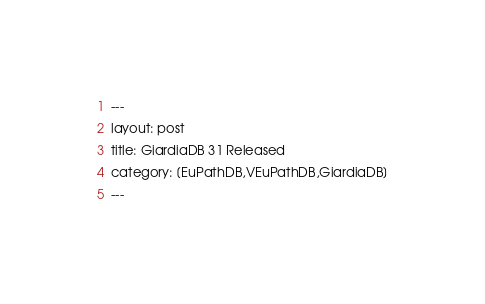Convert code to text. <code><loc_0><loc_0><loc_500><loc_500><_HTML_>---
layout: post
title: GiardiaDB 31 Released
category: [EuPathDB,VEuPathDB,GiardiaDB]
---
</code> 